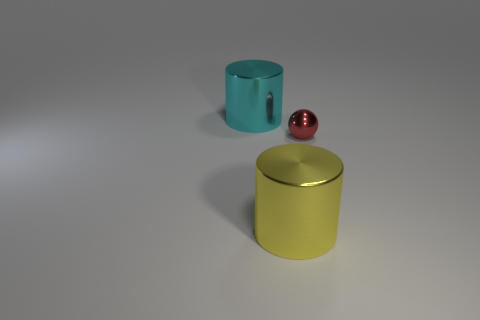Subtract all brown spheres. Subtract all red cylinders. How many spheres are left? 1 Add 1 green metal cubes. How many objects exist? 4 Subtract all balls. How many objects are left? 2 Add 2 small red shiny balls. How many small red shiny balls are left? 3 Add 1 metal things. How many metal things exist? 4 Subtract 1 cyan cylinders. How many objects are left? 2 Subtract all red spheres. Subtract all spheres. How many objects are left? 1 